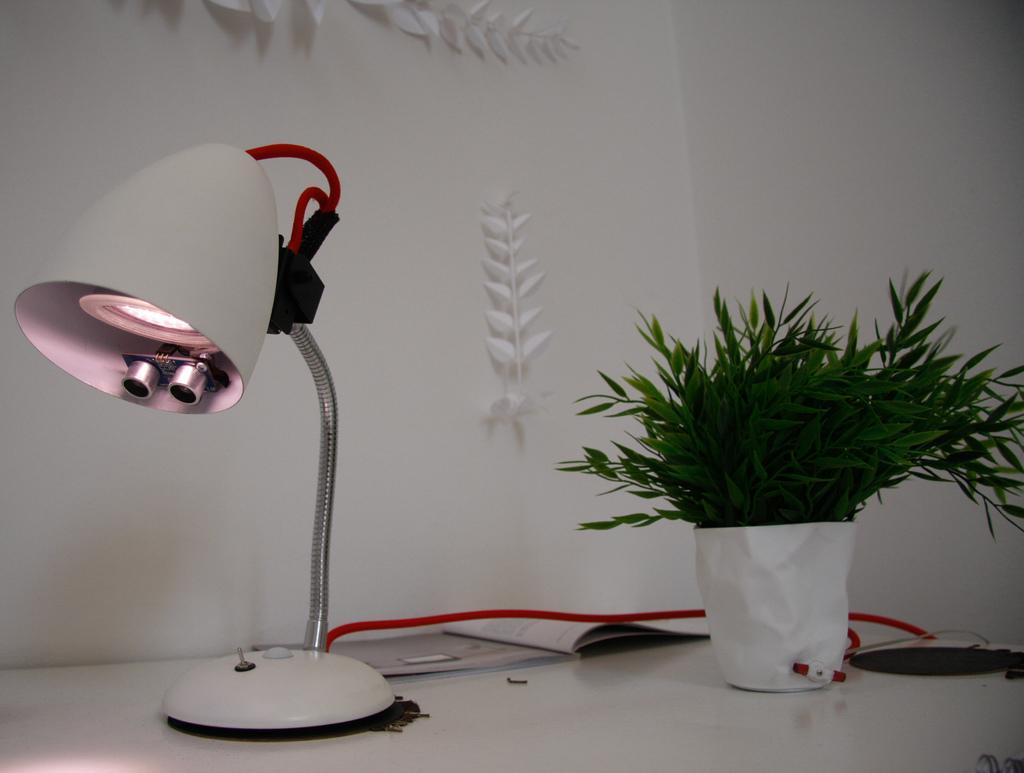Can you describe this image briefly? In this image we can see a table lamp, plant on the white color surface. In the background of the image there is wall. 